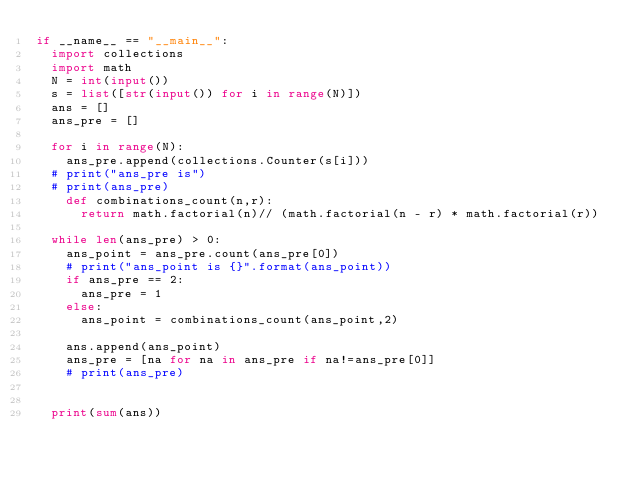Convert code to text. <code><loc_0><loc_0><loc_500><loc_500><_Python_>if __name__ == "__main__":
	import collections
	import math
	N = int(input())
	s = list([str(input()) for i in range(N)])
	ans = []
	ans_pre = []
	
	for i in range(N):
		ans_pre.append(collections.Counter(s[i]))
	# print("ans_pre is")
	# print(ans_pre)
		def combinations_count(n,r):
			return math.factorial(n)// (math.factorial(n - r) * math.factorial(r))

	while len(ans_pre) > 0:
		ans_point = ans_pre.count(ans_pre[0])
		# print("ans_point is {}".format(ans_point))
		if ans_pre == 2:
			ans_pre = 1
		else:
			ans_point = combinations_count(ans_point,2)

		ans.append(ans_point)
		ans_pre = [na for na in ans_pre if na!=ans_pre[0]]
		# print(ans_pre)


	print(sum(ans))</code> 